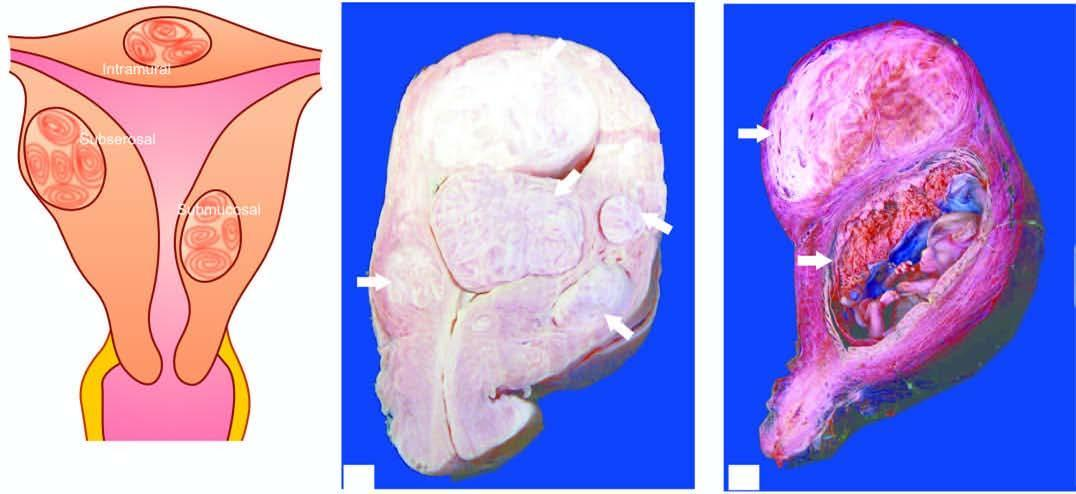what shows an intrauterine gestation sac with placenta having grey-white whorled pattern?
Answer the question using a single word or phrase. Opened up uterine cavity 